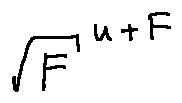Convert formula to latex. <formula><loc_0><loc_0><loc_500><loc_500>\sqrt { F } ^ { u + F }</formula> 